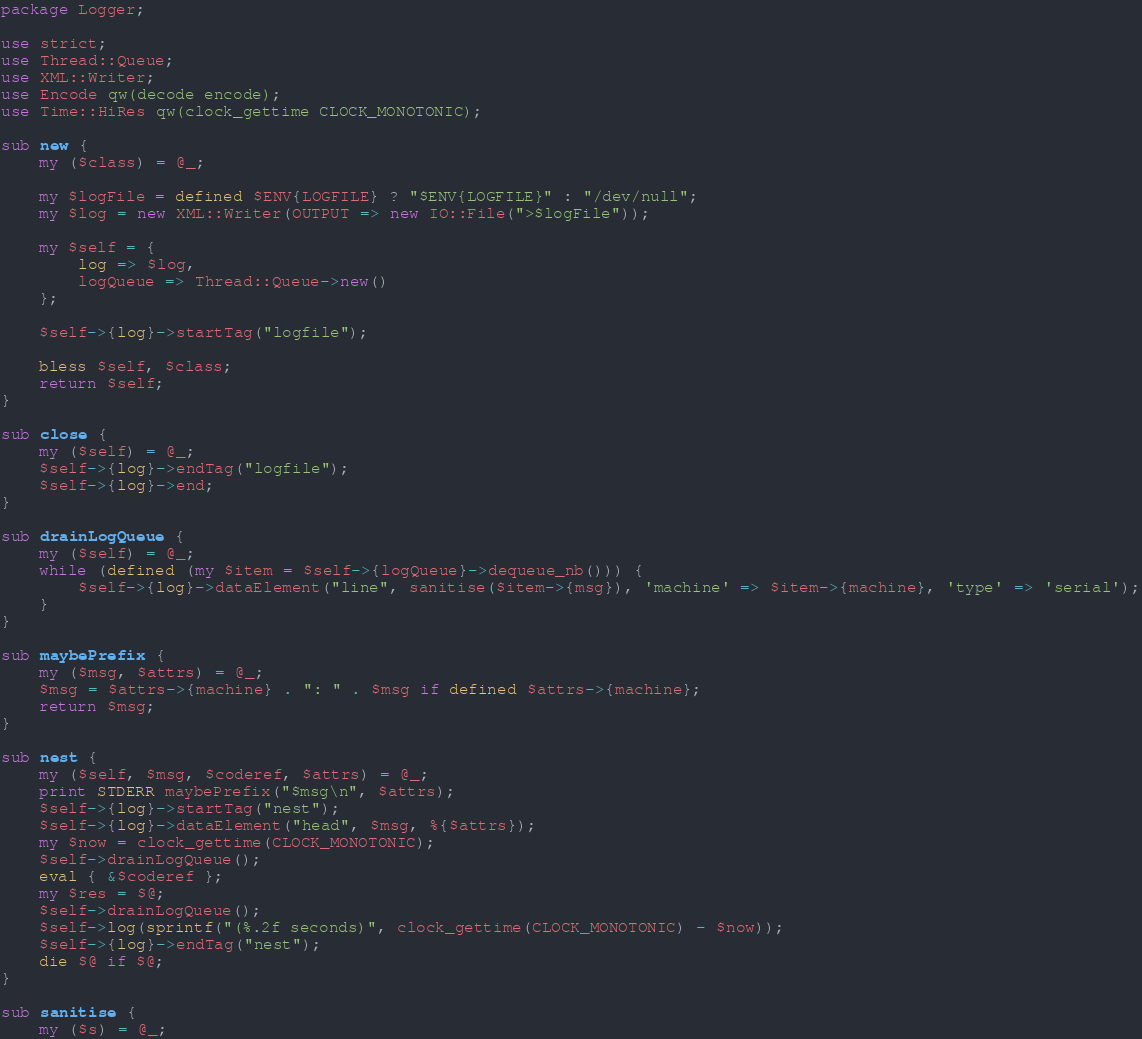Convert code to text. <code><loc_0><loc_0><loc_500><loc_500><_Perl_>package Logger;

use strict;
use Thread::Queue;
use XML::Writer;
use Encode qw(decode encode);
use Time::HiRes qw(clock_gettime CLOCK_MONOTONIC);

sub new {
    my ($class) = @_;
    
    my $logFile = defined $ENV{LOGFILE} ? "$ENV{LOGFILE}" : "/dev/null";
    my $log = new XML::Writer(OUTPUT => new IO::File(">$logFile"));
    
    my $self = {
        log => $log,
        logQueue => Thread::Queue->new()
    };
    
    $self->{log}->startTag("logfile");
    
    bless $self, $class;
    return $self;
}

sub close {
    my ($self) = @_;
    $self->{log}->endTag("logfile");
    $self->{log}->end;
}

sub drainLogQueue {
    my ($self) = @_;
    while (defined (my $item = $self->{logQueue}->dequeue_nb())) {
        $self->{log}->dataElement("line", sanitise($item->{msg}), 'machine' => $item->{machine}, 'type' => 'serial');
    }
}

sub maybePrefix {
    my ($msg, $attrs) = @_;
    $msg = $attrs->{machine} . ": " . $msg if defined $attrs->{machine};
    return $msg;
}

sub nest {
    my ($self, $msg, $coderef, $attrs) = @_;
    print STDERR maybePrefix("$msg\n", $attrs);
    $self->{log}->startTag("nest");
    $self->{log}->dataElement("head", $msg, %{$attrs});
    my $now = clock_gettime(CLOCK_MONOTONIC);
    $self->drainLogQueue();
    eval { &$coderef };
    my $res = $@;
    $self->drainLogQueue();
    $self->log(sprintf("(%.2f seconds)", clock_gettime(CLOCK_MONOTONIC) - $now));
    $self->{log}->endTag("nest");
    die $@ if $@;
}

sub sanitise {
    my ($s) = @_;</code> 